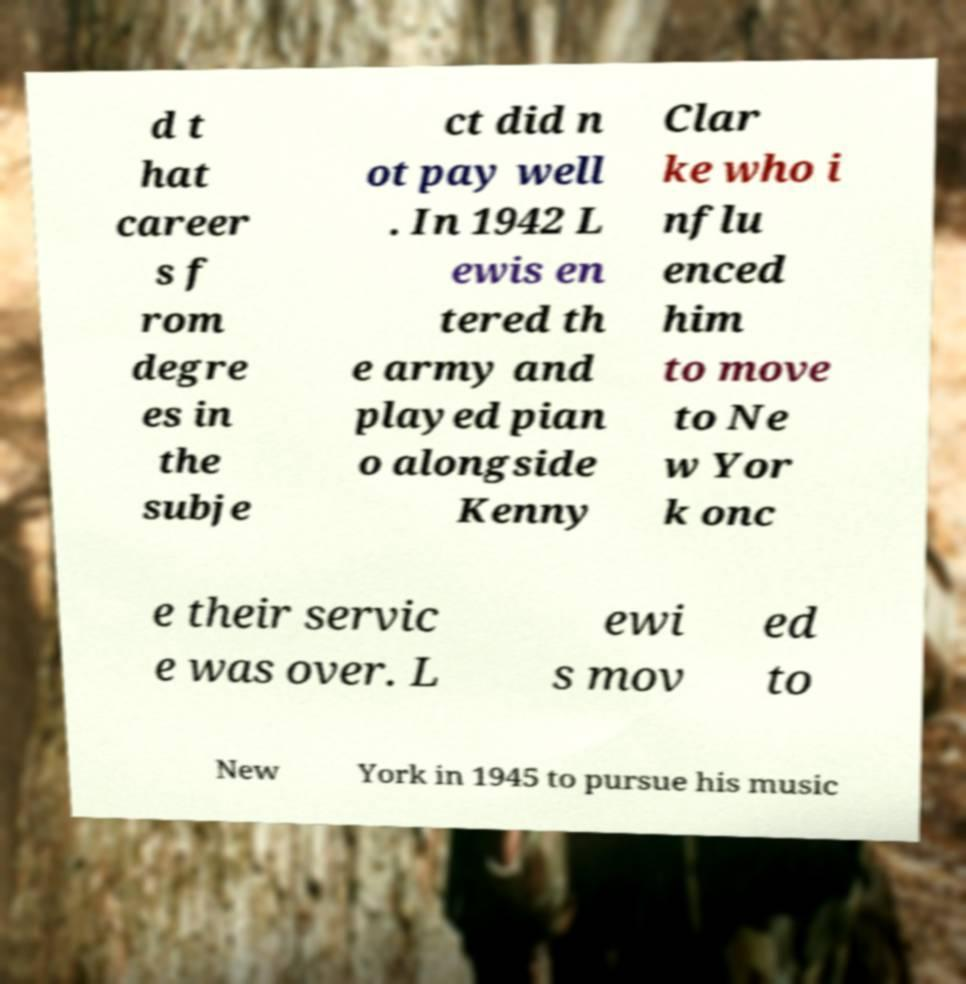I need the written content from this picture converted into text. Can you do that? d t hat career s f rom degre es in the subje ct did n ot pay well . In 1942 L ewis en tered th e army and played pian o alongside Kenny Clar ke who i nflu enced him to move to Ne w Yor k onc e their servic e was over. L ewi s mov ed to New York in 1945 to pursue his music 